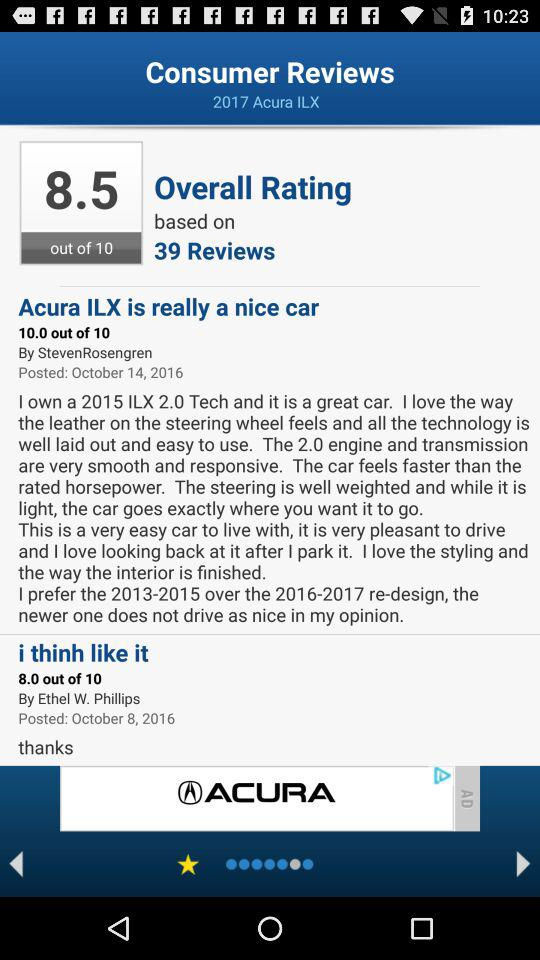What's the overall rating out of 10? The overall rating is 8.5. 